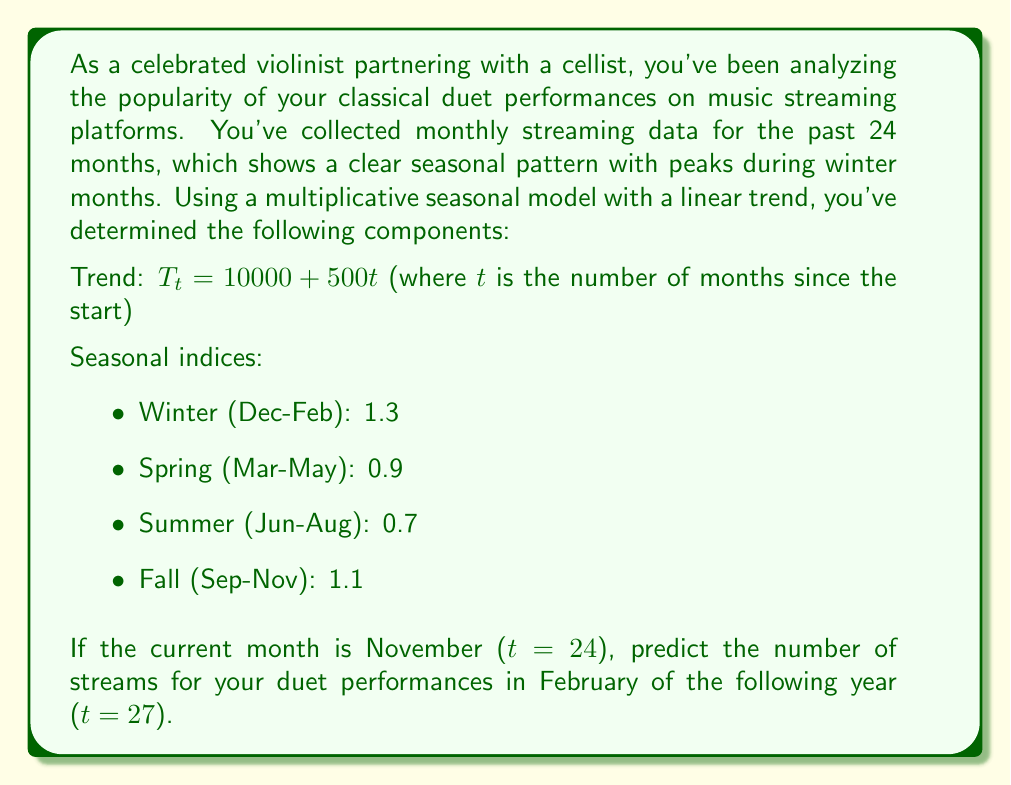Provide a solution to this math problem. To solve this problem, we'll use the multiplicative seasonal model, which is given by the formula:

$$ Y_t = T_t \times S_t \times I_t $$

Where:
$Y_t$ is the predicted value
$T_t$ is the trend component
$S_t$ is the seasonal component
$I_t$ is the irregular component (assumed to be 1 for forecasting)

Let's follow these steps:

1) Calculate the trend component for t=27:
   $T_{27} = 10000 + 500(27) = 23500$

2) Identify the seasonal index for February (winter):
   $S_{27} = 1.3$

3) Apply the multiplicative model:
   $Y_{27} = T_{27} \times S_{27} \times I_{27}$
   $Y_{27} = 23500 \times 1.3 \times 1$

4) Calculate the final result:
   $Y_{27} = 30550$

Therefore, the predicted number of streams for February of the following year is 30,550.
Answer: 30,550 streams 